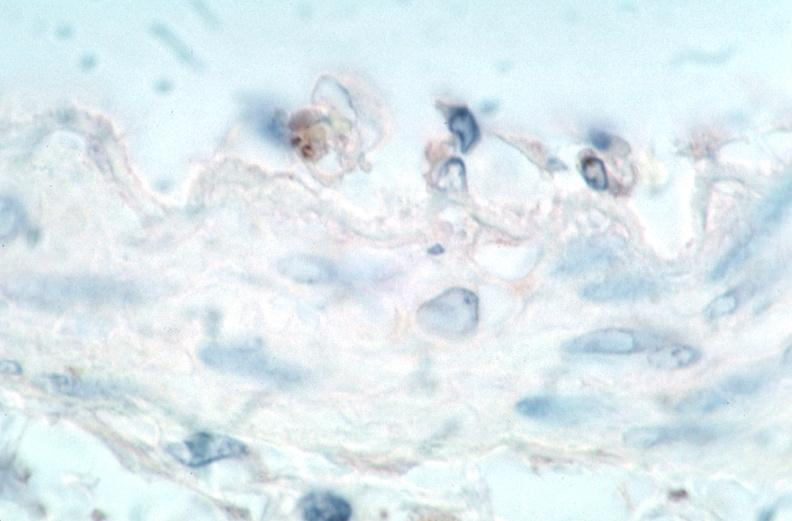s vasculature present?
Answer the question using a single word or phrase. Yes 